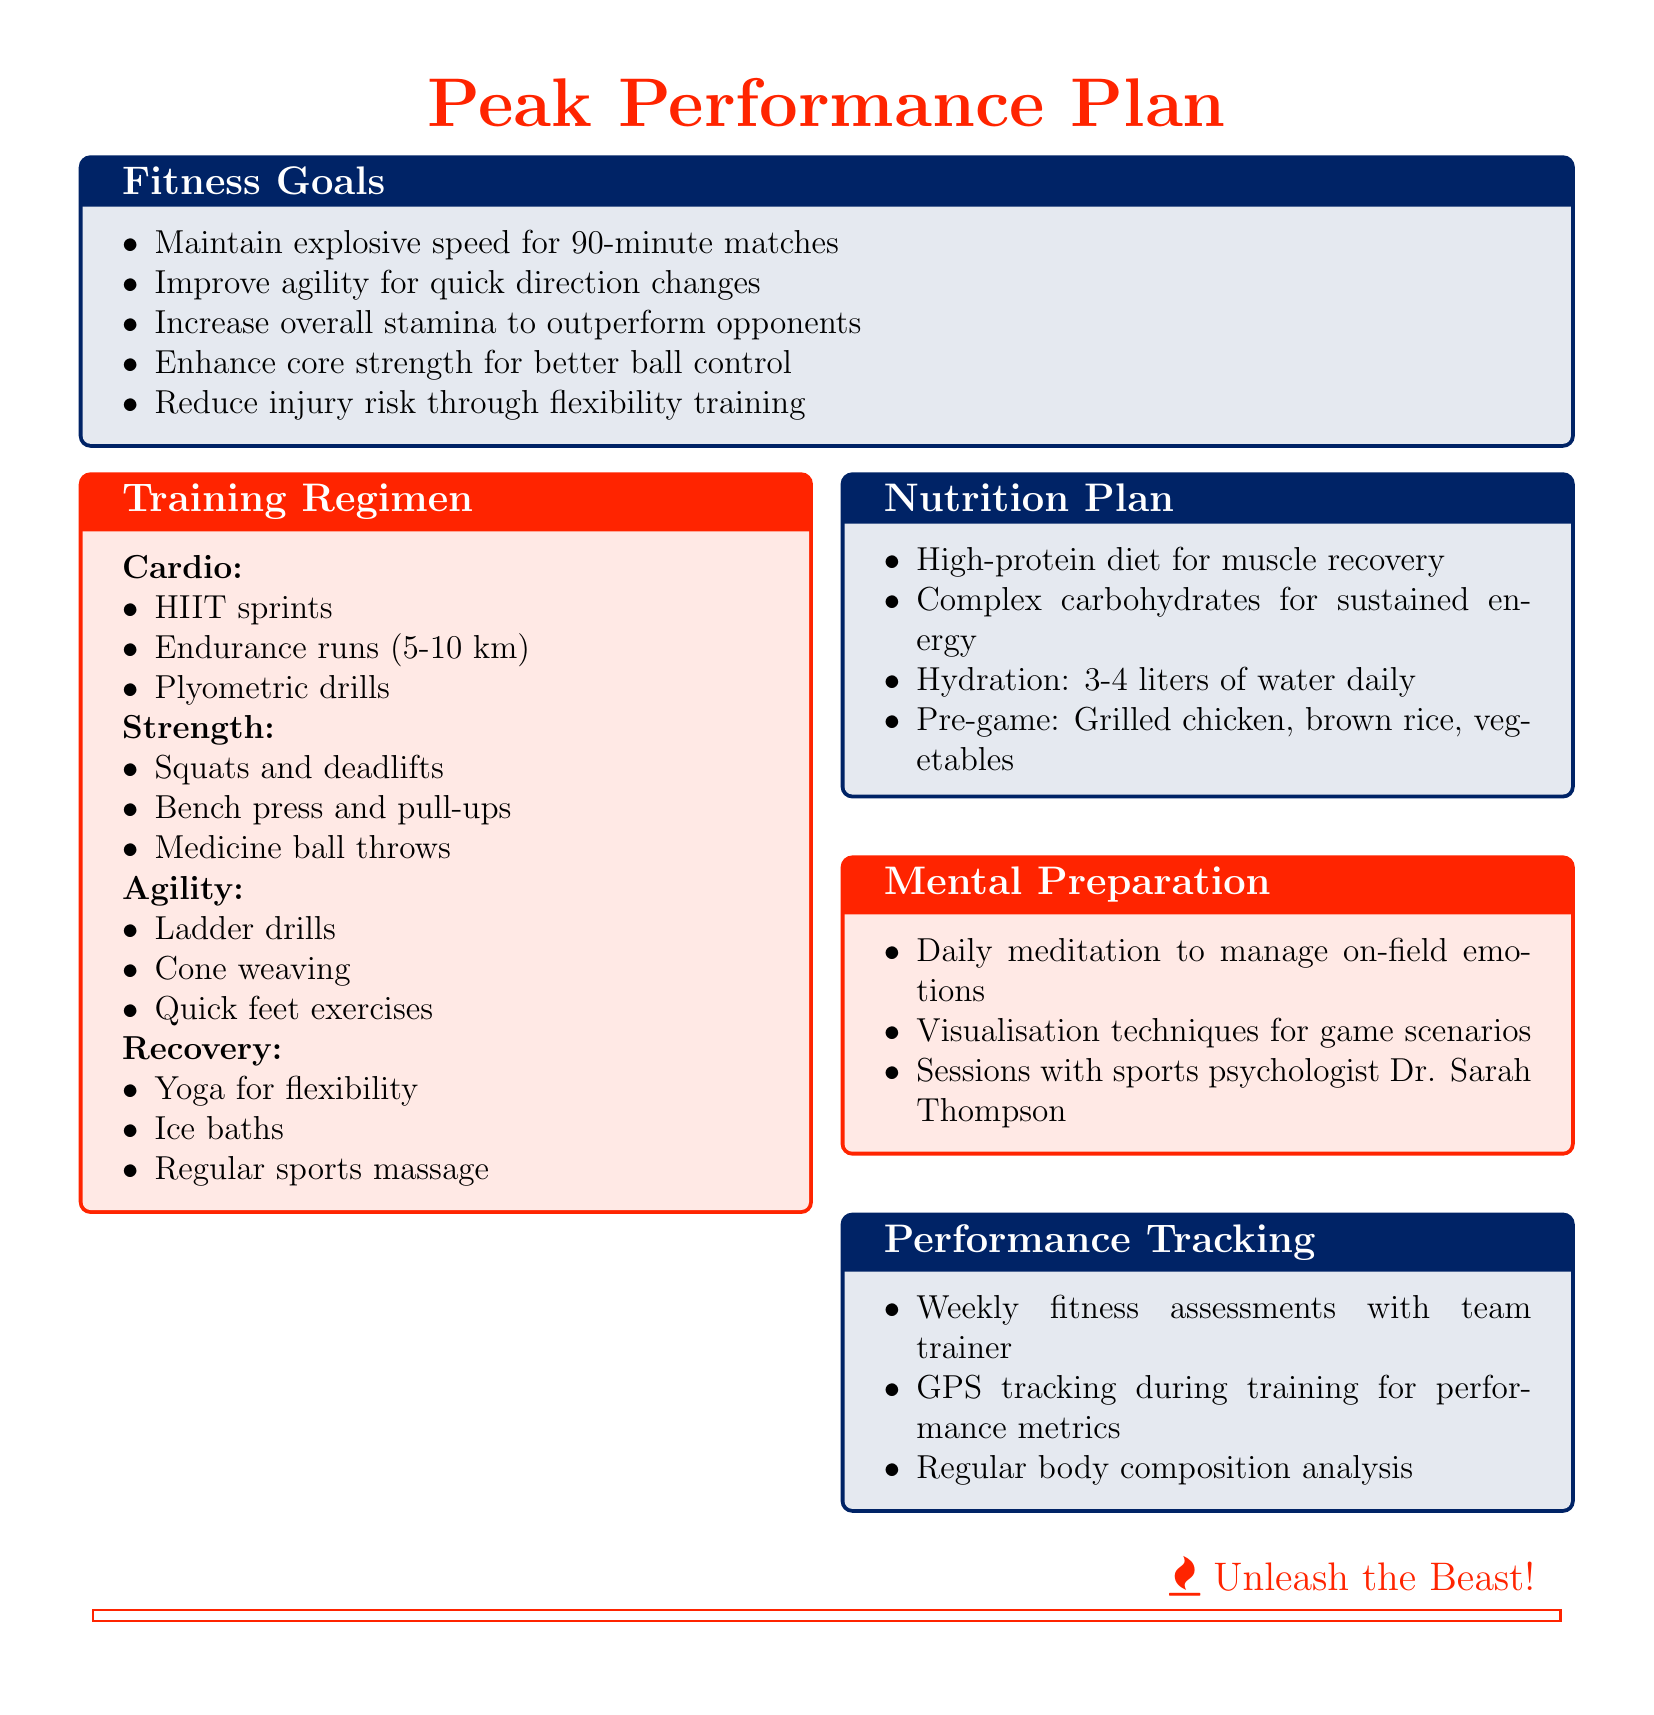what is one of the fitness goals? One of the fitness goals listed in the document is to maintain explosive speed for 90-minute matches.
Answer: maintain explosive speed for 90-minute matches how many exercises are listed under the Strength category? There are three exercises listed under the Strength category: squats and deadlifts, bench press and pull-ups, and medicine ball throws.
Answer: 3 what activity is included in the Recovery category? One of the activities included in the Recovery category is yoga for flexibility and mental focus.
Answer: yoga for flexibility what is the hydration strategy mentioned in the Nutrition Plan? The hydration strategy mentioned in the Nutrition Plan specifies a daily intake of 3-4 liters of water.
Answer: 3-4 liters of water daily who is the sports psychologist mentioned in the Mental Preparation section? The sports psychologist mentioned is Dr. Sarah Thompson.
Answer: Dr. Sarah Thompson what type of training is included in the Cardio category? High-intensity interval training (HIIT) sprints are included in the Cardio category.
Answer: HIIT sprints how often are fitness assessments conducted according to the Performance Tracking section? Fitness assessments are conducted weekly with the team trainer.
Answer: weekly which type of drills are suggested to improve agility? Ladder drills are suggested to improve agility.
Answer: Ladder drills 